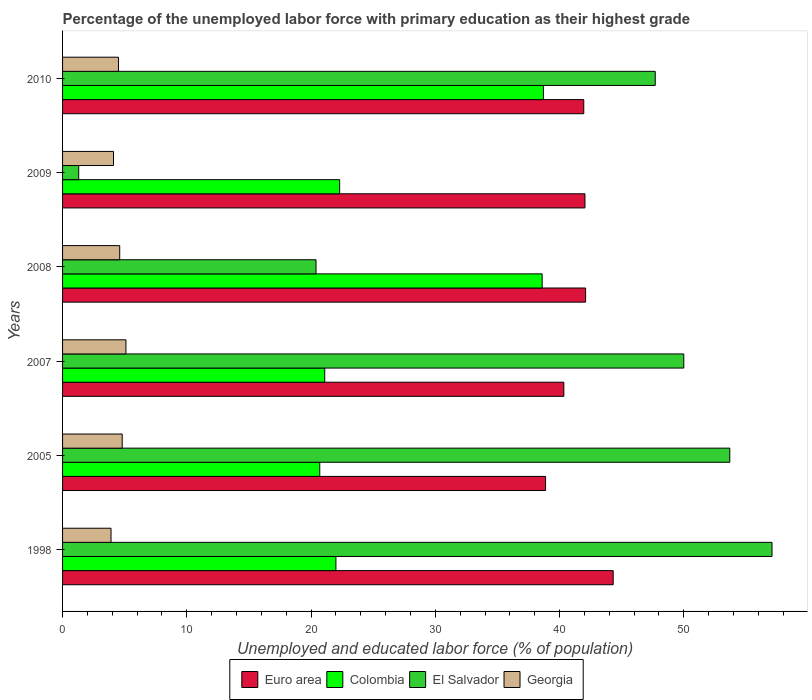How many different coloured bars are there?
Offer a terse response. 4. How many groups of bars are there?
Provide a succinct answer. 6. Are the number of bars on each tick of the Y-axis equal?
Give a very brief answer. Yes. How many bars are there on the 3rd tick from the top?
Offer a terse response. 4. What is the percentage of the unemployed labor force with primary education in Euro area in 2005?
Give a very brief answer. 38.87. Across all years, what is the maximum percentage of the unemployed labor force with primary education in El Salvador?
Offer a terse response. 57.1. Across all years, what is the minimum percentage of the unemployed labor force with primary education in Georgia?
Provide a short and direct response. 3.9. In which year was the percentage of the unemployed labor force with primary education in Georgia maximum?
Ensure brevity in your answer.  2007. What is the total percentage of the unemployed labor force with primary education in Georgia in the graph?
Keep it short and to the point. 27. What is the difference between the percentage of the unemployed labor force with primary education in Colombia in 1998 and that in 2009?
Your answer should be compact. -0.3. What is the difference between the percentage of the unemployed labor force with primary education in Euro area in 2008 and the percentage of the unemployed labor force with primary education in El Salvador in 2007?
Your answer should be compact. -7.9. What is the average percentage of the unemployed labor force with primary education in Colombia per year?
Offer a terse response. 27.23. In the year 2007, what is the difference between the percentage of the unemployed labor force with primary education in Euro area and percentage of the unemployed labor force with primary education in Colombia?
Offer a very short reply. 19.24. What is the ratio of the percentage of the unemployed labor force with primary education in Colombia in 2009 to that in 2010?
Provide a succinct answer. 0.58. Is the percentage of the unemployed labor force with primary education in Euro area in 2007 less than that in 2009?
Your answer should be very brief. Yes. What is the difference between the highest and the second highest percentage of the unemployed labor force with primary education in Colombia?
Offer a terse response. 0.1. What is the difference between the highest and the lowest percentage of the unemployed labor force with primary education in El Salvador?
Offer a terse response. 55.8. What does the 4th bar from the top in 2010 represents?
Make the answer very short. Euro area. What does the 4th bar from the bottom in 2005 represents?
Your answer should be compact. Georgia. Is it the case that in every year, the sum of the percentage of the unemployed labor force with primary education in Colombia and percentage of the unemployed labor force with primary education in El Salvador is greater than the percentage of the unemployed labor force with primary education in Georgia?
Give a very brief answer. Yes. How many bars are there?
Provide a short and direct response. 24. Are all the bars in the graph horizontal?
Your response must be concise. Yes. How many years are there in the graph?
Your response must be concise. 6. What is the difference between two consecutive major ticks on the X-axis?
Make the answer very short. 10. Does the graph contain any zero values?
Your response must be concise. No. Does the graph contain grids?
Make the answer very short. No. How are the legend labels stacked?
Give a very brief answer. Horizontal. What is the title of the graph?
Provide a succinct answer. Percentage of the unemployed labor force with primary education as their highest grade. What is the label or title of the X-axis?
Make the answer very short. Unemployed and educated labor force (% of population). What is the Unemployed and educated labor force (% of population) in Euro area in 1998?
Keep it short and to the point. 44.32. What is the Unemployed and educated labor force (% of population) of El Salvador in 1998?
Provide a succinct answer. 57.1. What is the Unemployed and educated labor force (% of population) in Georgia in 1998?
Give a very brief answer. 3.9. What is the Unemployed and educated labor force (% of population) in Euro area in 2005?
Make the answer very short. 38.87. What is the Unemployed and educated labor force (% of population) in Colombia in 2005?
Make the answer very short. 20.7. What is the Unemployed and educated labor force (% of population) in El Salvador in 2005?
Ensure brevity in your answer.  53.7. What is the Unemployed and educated labor force (% of population) of Georgia in 2005?
Give a very brief answer. 4.8. What is the Unemployed and educated labor force (% of population) in Euro area in 2007?
Provide a short and direct response. 40.34. What is the Unemployed and educated labor force (% of population) in Colombia in 2007?
Offer a very short reply. 21.1. What is the Unemployed and educated labor force (% of population) in El Salvador in 2007?
Provide a short and direct response. 50. What is the Unemployed and educated labor force (% of population) of Georgia in 2007?
Make the answer very short. 5.1. What is the Unemployed and educated labor force (% of population) of Euro area in 2008?
Keep it short and to the point. 42.1. What is the Unemployed and educated labor force (% of population) of Colombia in 2008?
Your answer should be very brief. 38.6. What is the Unemployed and educated labor force (% of population) in El Salvador in 2008?
Keep it short and to the point. 20.4. What is the Unemployed and educated labor force (% of population) in Georgia in 2008?
Offer a very short reply. 4.6. What is the Unemployed and educated labor force (% of population) in Euro area in 2009?
Provide a short and direct response. 42.04. What is the Unemployed and educated labor force (% of population) of Colombia in 2009?
Keep it short and to the point. 22.3. What is the Unemployed and educated labor force (% of population) in El Salvador in 2009?
Offer a very short reply. 1.3. What is the Unemployed and educated labor force (% of population) of Georgia in 2009?
Provide a succinct answer. 4.1. What is the Unemployed and educated labor force (% of population) in Euro area in 2010?
Provide a short and direct response. 41.95. What is the Unemployed and educated labor force (% of population) of Colombia in 2010?
Offer a terse response. 38.7. What is the Unemployed and educated labor force (% of population) of El Salvador in 2010?
Offer a terse response. 47.7. What is the Unemployed and educated labor force (% of population) of Georgia in 2010?
Your answer should be very brief. 4.5. Across all years, what is the maximum Unemployed and educated labor force (% of population) in Euro area?
Make the answer very short. 44.32. Across all years, what is the maximum Unemployed and educated labor force (% of population) in Colombia?
Offer a very short reply. 38.7. Across all years, what is the maximum Unemployed and educated labor force (% of population) in El Salvador?
Give a very brief answer. 57.1. Across all years, what is the maximum Unemployed and educated labor force (% of population) of Georgia?
Ensure brevity in your answer.  5.1. Across all years, what is the minimum Unemployed and educated labor force (% of population) of Euro area?
Your answer should be compact. 38.87. Across all years, what is the minimum Unemployed and educated labor force (% of population) in Colombia?
Offer a very short reply. 20.7. Across all years, what is the minimum Unemployed and educated labor force (% of population) of El Salvador?
Your response must be concise. 1.3. Across all years, what is the minimum Unemployed and educated labor force (% of population) of Georgia?
Your answer should be compact. 3.9. What is the total Unemployed and educated labor force (% of population) in Euro area in the graph?
Keep it short and to the point. 249.62. What is the total Unemployed and educated labor force (% of population) of Colombia in the graph?
Provide a short and direct response. 163.4. What is the total Unemployed and educated labor force (% of population) in El Salvador in the graph?
Provide a short and direct response. 230.2. What is the difference between the Unemployed and educated labor force (% of population) in Euro area in 1998 and that in 2005?
Your answer should be very brief. 5.44. What is the difference between the Unemployed and educated labor force (% of population) in Colombia in 1998 and that in 2005?
Your response must be concise. 1.3. What is the difference between the Unemployed and educated labor force (% of population) of Euro area in 1998 and that in 2007?
Provide a succinct answer. 3.97. What is the difference between the Unemployed and educated labor force (% of population) of Colombia in 1998 and that in 2007?
Provide a short and direct response. 0.9. What is the difference between the Unemployed and educated labor force (% of population) of Georgia in 1998 and that in 2007?
Your answer should be compact. -1.2. What is the difference between the Unemployed and educated labor force (% of population) of Euro area in 1998 and that in 2008?
Your response must be concise. 2.22. What is the difference between the Unemployed and educated labor force (% of population) in Colombia in 1998 and that in 2008?
Your answer should be very brief. -16.6. What is the difference between the Unemployed and educated labor force (% of population) in El Salvador in 1998 and that in 2008?
Provide a short and direct response. 36.7. What is the difference between the Unemployed and educated labor force (% of population) of Georgia in 1998 and that in 2008?
Provide a succinct answer. -0.7. What is the difference between the Unemployed and educated labor force (% of population) in Euro area in 1998 and that in 2009?
Offer a very short reply. 2.27. What is the difference between the Unemployed and educated labor force (% of population) of El Salvador in 1998 and that in 2009?
Offer a very short reply. 55.8. What is the difference between the Unemployed and educated labor force (% of population) of Georgia in 1998 and that in 2009?
Make the answer very short. -0.2. What is the difference between the Unemployed and educated labor force (% of population) of Euro area in 1998 and that in 2010?
Give a very brief answer. 2.37. What is the difference between the Unemployed and educated labor force (% of population) in Colombia in 1998 and that in 2010?
Your answer should be very brief. -16.7. What is the difference between the Unemployed and educated labor force (% of population) in El Salvador in 1998 and that in 2010?
Your answer should be compact. 9.4. What is the difference between the Unemployed and educated labor force (% of population) in Euro area in 2005 and that in 2007?
Provide a short and direct response. -1.47. What is the difference between the Unemployed and educated labor force (% of population) of Colombia in 2005 and that in 2007?
Make the answer very short. -0.4. What is the difference between the Unemployed and educated labor force (% of population) of El Salvador in 2005 and that in 2007?
Offer a terse response. 3.7. What is the difference between the Unemployed and educated labor force (% of population) of Euro area in 2005 and that in 2008?
Make the answer very short. -3.22. What is the difference between the Unemployed and educated labor force (% of population) of Colombia in 2005 and that in 2008?
Provide a short and direct response. -17.9. What is the difference between the Unemployed and educated labor force (% of population) in El Salvador in 2005 and that in 2008?
Offer a very short reply. 33.3. What is the difference between the Unemployed and educated labor force (% of population) of Georgia in 2005 and that in 2008?
Make the answer very short. 0.2. What is the difference between the Unemployed and educated labor force (% of population) in Euro area in 2005 and that in 2009?
Provide a short and direct response. -3.17. What is the difference between the Unemployed and educated labor force (% of population) in Colombia in 2005 and that in 2009?
Provide a short and direct response. -1.6. What is the difference between the Unemployed and educated labor force (% of population) in El Salvador in 2005 and that in 2009?
Your answer should be compact. 52.4. What is the difference between the Unemployed and educated labor force (% of population) in Georgia in 2005 and that in 2009?
Give a very brief answer. 0.7. What is the difference between the Unemployed and educated labor force (% of population) of Euro area in 2005 and that in 2010?
Provide a short and direct response. -3.08. What is the difference between the Unemployed and educated labor force (% of population) in Colombia in 2005 and that in 2010?
Offer a terse response. -18. What is the difference between the Unemployed and educated labor force (% of population) in Euro area in 2007 and that in 2008?
Give a very brief answer. -1.75. What is the difference between the Unemployed and educated labor force (% of population) of Colombia in 2007 and that in 2008?
Offer a very short reply. -17.5. What is the difference between the Unemployed and educated labor force (% of population) of El Salvador in 2007 and that in 2008?
Your answer should be compact. 29.6. What is the difference between the Unemployed and educated labor force (% of population) of Euro area in 2007 and that in 2009?
Your response must be concise. -1.7. What is the difference between the Unemployed and educated labor force (% of population) in El Salvador in 2007 and that in 2009?
Ensure brevity in your answer.  48.7. What is the difference between the Unemployed and educated labor force (% of population) in Euro area in 2007 and that in 2010?
Offer a terse response. -1.6. What is the difference between the Unemployed and educated labor force (% of population) in Colombia in 2007 and that in 2010?
Keep it short and to the point. -17.6. What is the difference between the Unemployed and educated labor force (% of population) of El Salvador in 2007 and that in 2010?
Provide a succinct answer. 2.3. What is the difference between the Unemployed and educated labor force (% of population) in Georgia in 2007 and that in 2010?
Ensure brevity in your answer.  0.6. What is the difference between the Unemployed and educated labor force (% of population) in Euro area in 2008 and that in 2009?
Your answer should be compact. 0.05. What is the difference between the Unemployed and educated labor force (% of population) of Colombia in 2008 and that in 2009?
Your response must be concise. 16.3. What is the difference between the Unemployed and educated labor force (% of population) in El Salvador in 2008 and that in 2009?
Provide a succinct answer. 19.1. What is the difference between the Unemployed and educated labor force (% of population) in Euro area in 2008 and that in 2010?
Keep it short and to the point. 0.15. What is the difference between the Unemployed and educated labor force (% of population) in El Salvador in 2008 and that in 2010?
Offer a very short reply. -27.3. What is the difference between the Unemployed and educated labor force (% of population) of Georgia in 2008 and that in 2010?
Provide a short and direct response. 0.1. What is the difference between the Unemployed and educated labor force (% of population) in Euro area in 2009 and that in 2010?
Give a very brief answer. 0.1. What is the difference between the Unemployed and educated labor force (% of population) in Colombia in 2009 and that in 2010?
Your response must be concise. -16.4. What is the difference between the Unemployed and educated labor force (% of population) in El Salvador in 2009 and that in 2010?
Offer a very short reply. -46.4. What is the difference between the Unemployed and educated labor force (% of population) of Georgia in 2009 and that in 2010?
Offer a terse response. -0.4. What is the difference between the Unemployed and educated labor force (% of population) in Euro area in 1998 and the Unemployed and educated labor force (% of population) in Colombia in 2005?
Provide a short and direct response. 23.62. What is the difference between the Unemployed and educated labor force (% of population) of Euro area in 1998 and the Unemployed and educated labor force (% of population) of El Salvador in 2005?
Your answer should be compact. -9.38. What is the difference between the Unemployed and educated labor force (% of population) of Euro area in 1998 and the Unemployed and educated labor force (% of population) of Georgia in 2005?
Give a very brief answer. 39.52. What is the difference between the Unemployed and educated labor force (% of population) of Colombia in 1998 and the Unemployed and educated labor force (% of population) of El Salvador in 2005?
Offer a terse response. -31.7. What is the difference between the Unemployed and educated labor force (% of population) in Colombia in 1998 and the Unemployed and educated labor force (% of population) in Georgia in 2005?
Provide a short and direct response. 17.2. What is the difference between the Unemployed and educated labor force (% of population) in El Salvador in 1998 and the Unemployed and educated labor force (% of population) in Georgia in 2005?
Your response must be concise. 52.3. What is the difference between the Unemployed and educated labor force (% of population) of Euro area in 1998 and the Unemployed and educated labor force (% of population) of Colombia in 2007?
Your answer should be compact. 23.22. What is the difference between the Unemployed and educated labor force (% of population) of Euro area in 1998 and the Unemployed and educated labor force (% of population) of El Salvador in 2007?
Ensure brevity in your answer.  -5.68. What is the difference between the Unemployed and educated labor force (% of population) in Euro area in 1998 and the Unemployed and educated labor force (% of population) in Georgia in 2007?
Offer a terse response. 39.22. What is the difference between the Unemployed and educated labor force (% of population) in Colombia in 1998 and the Unemployed and educated labor force (% of population) in El Salvador in 2007?
Your answer should be compact. -28. What is the difference between the Unemployed and educated labor force (% of population) in Colombia in 1998 and the Unemployed and educated labor force (% of population) in Georgia in 2007?
Make the answer very short. 16.9. What is the difference between the Unemployed and educated labor force (% of population) of El Salvador in 1998 and the Unemployed and educated labor force (% of population) of Georgia in 2007?
Ensure brevity in your answer.  52. What is the difference between the Unemployed and educated labor force (% of population) in Euro area in 1998 and the Unemployed and educated labor force (% of population) in Colombia in 2008?
Offer a very short reply. 5.72. What is the difference between the Unemployed and educated labor force (% of population) of Euro area in 1998 and the Unemployed and educated labor force (% of population) of El Salvador in 2008?
Keep it short and to the point. 23.92. What is the difference between the Unemployed and educated labor force (% of population) in Euro area in 1998 and the Unemployed and educated labor force (% of population) in Georgia in 2008?
Offer a very short reply. 39.72. What is the difference between the Unemployed and educated labor force (% of population) in El Salvador in 1998 and the Unemployed and educated labor force (% of population) in Georgia in 2008?
Ensure brevity in your answer.  52.5. What is the difference between the Unemployed and educated labor force (% of population) of Euro area in 1998 and the Unemployed and educated labor force (% of population) of Colombia in 2009?
Keep it short and to the point. 22.02. What is the difference between the Unemployed and educated labor force (% of population) of Euro area in 1998 and the Unemployed and educated labor force (% of population) of El Salvador in 2009?
Your response must be concise. 43.02. What is the difference between the Unemployed and educated labor force (% of population) of Euro area in 1998 and the Unemployed and educated labor force (% of population) of Georgia in 2009?
Provide a succinct answer. 40.22. What is the difference between the Unemployed and educated labor force (% of population) in Colombia in 1998 and the Unemployed and educated labor force (% of population) in El Salvador in 2009?
Your answer should be very brief. 20.7. What is the difference between the Unemployed and educated labor force (% of population) of Colombia in 1998 and the Unemployed and educated labor force (% of population) of Georgia in 2009?
Offer a very short reply. 17.9. What is the difference between the Unemployed and educated labor force (% of population) in Euro area in 1998 and the Unemployed and educated labor force (% of population) in Colombia in 2010?
Keep it short and to the point. 5.62. What is the difference between the Unemployed and educated labor force (% of population) in Euro area in 1998 and the Unemployed and educated labor force (% of population) in El Salvador in 2010?
Provide a succinct answer. -3.38. What is the difference between the Unemployed and educated labor force (% of population) of Euro area in 1998 and the Unemployed and educated labor force (% of population) of Georgia in 2010?
Make the answer very short. 39.82. What is the difference between the Unemployed and educated labor force (% of population) in Colombia in 1998 and the Unemployed and educated labor force (% of population) in El Salvador in 2010?
Give a very brief answer. -25.7. What is the difference between the Unemployed and educated labor force (% of population) in Colombia in 1998 and the Unemployed and educated labor force (% of population) in Georgia in 2010?
Your answer should be compact. 17.5. What is the difference between the Unemployed and educated labor force (% of population) of El Salvador in 1998 and the Unemployed and educated labor force (% of population) of Georgia in 2010?
Your answer should be very brief. 52.6. What is the difference between the Unemployed and educated labor force (% of population) of Euro area in 2005 and the Unemployed and educated labor force (% of population) of Colombia in 2007?
Provide a short and direct response. 17.77. What is the difference between the Unemployed and educated labor force (% of population) in Euro area in 2005 and the Unemployed and educated labor force (% of population) in El Salvador in 2007?
Provide a short and direct response. -11.13. What is the difference between the Unemployed and educated labor force (% of population) in Euro area in 2005 and the Unemployed and educated labor force (% of population) in Georgia in 2007?
Give a very brief answer. 33.77. What is the difference between the Unemployed and educated labor force (% of population) in Colombia in 2005 and the Unemployed and educated labor force (% of population) in El Salvador in 2007?
Provide a short and direct response. -29.3. What is the difference between the Unemployed and educated labor force (% of population) of El Salvador in 2005 and the Unemployed and educated labor force (% of population) of Georgia in 2007?
Ensure brevity in your answer.  48.6. What is the difference between the Unemployed and educated labor force (% of population) in Euro area in 2005 and the Unemployed and educated labor force (% of population) in Colombia in 2008?
Give a very brief answer. 0.27. What is the difference between the Unemployed and educated labor force (% of population) in Euro area in 2005 and the Unemployed and educated labor force (% of population) in El Salvador in 2008?
Provide a short and direct response. 18.47. What is the difference between the Unemployed and educated labor force (% of population) of Euro area in 2005 and the Unemployed and educated labor force (% of population) of Georgia in 2008?
Offer a terse response. 34.27. What is the difference between the Unemployed and educated labor force (% of population) in Colombia in 2005 and the Unemployed and educated labor force (% of population) in El Salvador in 2008?
Make the answer very short. 0.3. What is the difference between the Unemployed and educated labor force (% of population) of Colombia in 2005 and the Unemployed and educated labor force (% of population) of Georgia in 2008?
Your response must be concise. 16.1. What is the difference between the Unemployed and educated labor force (% of population) of El Salvador in 2005 and the Unemployed and educated labor force (% of population) of Georgia in 2008?
Offer a terse response. 49.1. What is the difference between the Unemployed and educated labor force (% of population) of Euro area in 2005 and the Unemployed and educated labor force (% of population) of Colombia in 2009?
Your answer should be compact. 16.57. What is the difference between the Unemployed and educated labor force (% of population) in Euro area in 2005 and the Unemployed and educated labor force (% of population) in El Salvador in 2009?
Ensure brevity in your answer.  37.57. What is the difference between the Unemployed and educated labor force (% of population) in Euro area in 2005 and the Unemployed and educated labor force (% of population) in Georgia in 2009?
Your answer should be compact. 34.77. What is the difference between the Unemployed and educated labor force (% of population) of Colombia in 2005 and the Unemployed and educated labor force (% of population) of Georgia in 2009?
Ensure brevity in your answer.  16.6. What is the difference between the Unemployed and educated labor force (% of population) in El Salvador in 2005 and the Unemployed and educated labor force (% of population) in Georgia in 2009?
Keep it short and to the point. 49.6. What is the difference between the Unemployed and educated labor force (% of population) in Euro area in 2005 and the Unemployed and educated labor force (% of population) in Colombia in 2010?
Provide a short and direct response. 0.17. What is the difference between the Unemployed and educated labor force (% of population) of Euro area in 2005 and the Unemployed and educated labor force (% of population) of El Salvador in 2010?
Make the answer very short. -8.83. What is the difference between the Unemployed and educated labor force (% of population) in Euro area in 2005 and the Unemployed and educated labor force (% of population) in Georgia in 2010?
Give a very brief answer. 34.37. What is the difference between the Unemployed and educated labor force (% of population) of Colombia in 2005 and the Unemployed and educated labor force (% of population) of Georgia in 2010?
Keep it short and to the point. 16.2. What is the difference between the Unemployed and educated labor force (% of population) of El Salvador in 2005 and the Unemployed and educated labor force (% of population) of Georgia in 2010?
Your answer should be compact. 49.2. What is the difference between the Unemployed and educated labor force (% of population) in Euro area in 2007 and the Unemployed and educated labor force (% of population) in Colombia in 2008?
Provide a succinct answer. 1.75. What is the difference between the Unemployed and educated labor force (% of population) in Euro area in 2007 and the Unemployed and educated labor force (% of population) in El Salvador in 2008?
Keep it short and to the point. 19.95. What is the difference between the Unemployed and educated labor force (% of population) of Euro area in 2007 and the Unemployed and educated labor force (% of population) of Georgia in 2008?
Your response must be concise. 35.74. What is the difference between the Unemployed and educated labor force (% of population) in Colombia in 2007 and the Unemployed and educated labor force (% of population) in Georgia in 2008?
Provide a short and direct response. 16.5. What is the difference between the Unemployed and educated labor force (% of population) of El Salvador in 2007 and the Unemployed and educated labor force (% of population) of Georgia in 2008?
Offer a very short reply. 45.4. What is the difference between the Unemployed and educated labor force (% of population) of Euro area in 2007 and the Unemployed and educated labor force (% of population) of Colombia in 2009?
Your answer should be compact. 18.05. What is the difference between the Unemployed and educated labor force (% of population) of Euro area in 2007 and the Unemployed and educated labor force (% of population) of El Salvador in 2009?
Your response must be concise. 39.05. What is the difference between the Unemployed and educated labor force (% of population) of Euro area in 2007 and the Unemployed and educated labor force (% of population) of Georgia in 2009?
Your answer should be very brief. 36.24. What is the difference between the Unemployed and educated labor force (% of population) in Colombia in 2007 and the Unemployed and educated labor force (% of population) in El Salvador in 2009?
Ensure brevity in your answer.  19.8. What is the difference between the Unemployed and educated labor force (% of population) of Colombia in 2007 and the Unemployed and educated labor force (% of population) of Georgia in 2009?
Keep it short and to the point. 17. What is the difference between the Unemployed and educated labor force (% of population) of El Salvador in 2007 and the Unemployed and educated labor force (% of population) of Georgia in 2009?
Keep it short and to the point. 45.9. What is the difference between the Unemployed and educated labor force (% of population) in Euro area in 2007 and the Unemployed and educated labor force (% of population) in Colombia in 2010?
Give a very brief answer. 1.65. What is the difference between the Unemployed and educated labor force (% of population) in Euro area in 2007 and the Unemployed and educated labor force (% of population) in El Salvador in 2010?
Your response must be concise. -7.36. What is the difference between the Unemployed and educated labor force (% of population) of Euro area in 2007 and the Unemployed and educated labor force (% of population) of Georgia in 2010?
Your response must be concise. 35.84. What is the difference between the Unemployed and educated labor force (% of population) in Colombia in 2007 and the Unemployed and educated labor force (% of population) in El Salvador in 2010?
Your response must be concise. -26.6. What is the difference between the Unemployed and educated labor force (% of population) in El Salvador in 2007 and the Unemployed and educated labor force (% of population) in Georgia in 2010?
Keep it short and to the point. 45.5. What is the difference between the Unemployed and educated labor force (% of population) of Euro area in 2008 and the Unemployed and educated labor force (% of population) of Colombia in 2009?
Keep it short and to the point. 19.8. What is the difference between the Unemployed and educated labor force (% of population) in Euro area in 2008 and the Unemployed and educated labor force (% of population) in El Salvador in 2009?
Give a very brief answer. 40.8. What is the difference between the Unemployed and educated labor force (% of population) of Euro area in 2008 and the Unemployed and educated labor force (% of population) of Georgia in 2009?
Provide a short and direct response. 38. What is the difference between the Unemployed and educated labor force (% of population) in Colombia in 2008 and the Unemployed and educated labor force (% of population) in El Salvador in 2009?
Your response must be concise. 37.3. What is the difference between the Unemployed and educated labor force (% of population) in Colombia in 2008 and the Unemployed and educated labor force (% of population) in Georgia in 2009?
Your answer should be compact. 34.5. What is the difference between the Unemployed and educated labor force (% of population) of El Salvador in 2008 and the Unemployed and educated labor force (% of population) of Georgia in 2009?
Your response must be concise. 16.3. What is the difference between the Unemployed and educated labor force (% of population) of Euro area in 2008 and the Unemployed and educated labor force (% of population) of Colombia in 2010?
Your response must be concise. 3.4. What is the difference between the Unemployed and educated labor force (% of population) in Euro area in 2008 and the Unemployed and educated labor force (% of population) in El Salvador in 2010?
Keep it short and to the point. -5.6. What is the difference between the Unemployed and educated labor force (% of population) of Euro area in 2008 and the Unemployed and educated labor force (% of population) of Georgia in 2010?
Your answer should be very brief. 37.6. What is the difference between the Unemployed and educated labor force (% of population) of Colombia in 2008 and the Unemployed and educated labor force (% of population) of El Salvador in 2010?
Make the answer very short. -9.1. What is the difference between the Unemployed and educated labor force (% of population) in Colombia in 2008 and the Unemployed and educated labor force (% of population) in Georgia in 2010?
Your answer should be very brief. 34.1. What is the difference between the Unemployed and educated labor force (% of population) in El Salvador in 2008 and the Unemployed and educated labor force (% of population) in Georgia in 2010?
Your answer should be very brief. 15.9. What is the difference between the Unemployed and educated labor force (% of population) of Euro area in 2009 and the Unemployed and educated labor force (% of population) of Colombia in 2010?
Provide a succinct answer. 3.34. What is the difference between the Unemployed and educated labor force (% of population) in Euro area in 2009 and the Unemployed and educated labor force (% of population) in El Salvador in 2010?
Ensure brevity in your answer.  -5.66. What is the difference between the Unemployed and educated labor force (% of population) of Euro area in 2009 and the Unemployed and educated labor force (% of population) of Georgia in 2010?
Offer a very short reply. 37.54. What is the difference between the Unemployed and educated labor force (% of population) of Colombia in 2009 and the Unemployed and educated labor force (% of population) of El Salvador in 2010?
Offer a very short reply. -25.4. What is the difference between the Unemployed and educated labor force (% of population) of Colombia in 2009 and the Unemployed and educated labor force (% of population) of Georgia in 2010?
Provide a succinct answer. 17.8. What is the average Unemployed and educated labor force (% of population) in Euro area per year?
Offer a terse response. 41.6. What is the average Unemployed and educated labor force (% of population) of Colombia per year?
Ensure brevity in your answer.  27.23. What is the average Unemployed and educated labor force (% of population) in El Salvador per year?
Make the answer very short. 38.37. In the year 1998, what is the difference between the Unemployed and educated labor force (% of population) of Euro area and Unemployed and educated labor force (% of population) of Colombia?
Your answer should be compact. 22.32. In the year 1998, what is the difference between the Unemployed and educated labor force (% of population) of Euro area and Unemployed and educated labor force (% of population) of El Salvador?
Your answer should be very brief. -12.78. In the year 1998, what is the difference between the Unemployed and educated labor force (% of population) of Euro area and Unemployed and educated labor force (% of population) of Georgia?
Offer a terse response. 40.42. In the year 1998, what is the difference between the Unemployed and educated labor force (% of population) of Colombia and Unemployed and educated labor force (% of population) of El Salvador?
Give a very brief answer. -35.1. In the year 1998, what is the difference between the Unemployed and educated labor force (% of population) in Colombia and Unemployed and educated labor force (% of population) in Georgia?
Make the answer very short. 18.1. In the year 1998, what is the difference between the Unemployed and educated labor force (% of population) in El Salvador and Unemployed and educated labor force (% of population) in Georgia?
Your answer should be compact. 53.2. In the year 2005, what is the difference between the Unemployed and educated labor force (% of population) of Euro area and Unemployed and educated labor force (% of population) of Colombia?
Keep it short and to the point. 18.17. In the year 2005, what is the difference between the Unemployed and educated labor force (% of population) in Euro area and Unemployed and educated labor force (% of population) in El Salvador?
Keep it short and to the point. -14.83. In the year 2005, what is the difference between the Unemployed and educated labor force (% of population) of Euro area and Unemployed and educated labor force (% of population) of Georgia?
Your answer should be compact. 34.07. In the year 2005, what is the difference between the Unemployed and educated labor force (% of population) in Colombia and Unemployed and educated labor force (% of population) in El Salvador?
Offer a terse response. -33. In the year 2005, what is the difference between the Unemployed and educated labor force (% of population) of Colombia and Unemployed and educated labor force (% of population) of Georgia?
Ensure brevity in your answer.  15.9. In the year 2005, what is the difference between the Unemployed and educated labor force (% of population) in El Salvador and Unemployed and educated labor force (% of population) in Georgia?
Make the answer very short. 48.9. In the year 2007, what is the difference between the Unemployed and educated labor force (% of population) in Euro area and Unemployed and educated labor force (% of population) in Colombia?
Offer a terse response. 19.25. In the year 2007, what is the difference between the Unemployed and educated labor force (% of population) of Euro area and Unemployed and educated labor force (% of population) of El Salvador?
Your response must be concise. -9.65. In the year 2007, what is the difference between the Unemployed and educated labor force (% of population) in Euro area and Unemployed and educated labor force (% of population) in Georgia?
Make the answer very short. 35.24. In the year 2007, what is the difference between the Unemployed and educated labor force (% of population) in Colombia and Unemployed and educated labor force (% of population) in El Salvador?
Offer a terse response. -28.9. In the year 2007, what is the difference between the Unemployed and educated labor force (% of population) in El Salvador and Unemployed and educated labor force (% of population) in Georgia?
Keep it short and to the point. 44.9. In the year 2008, what is the difference between the Unemployed and educated labor force (% of population) in Euro area and Unemployed and educated labor force (% of population) in Colombia?
Give a very brief answer. 3.5. In the year 2008, what is the difference between the Unemployed and educated labor force (% of population) of Euro area and Unemployed and educated labor force (% of population) of El Salvador?
Your answer should be very brief. 21.7. In the year 2008, what is the difference between the Unemployed and educated labor force (% of population) in Euro area and Unemployed and educated labor force (% of population) in Georgia?
Offer a very short reply. 37.5. In the year 2008, what is the difference between the Unemployed and educated labor force (% of population) in Colombia and Unemployed and educated labor force (% of population) in El Salvador?
Your response must be concise. 18.2. In the year 2008, what is the difference between the Unemployed and educated labor force (% of population) of El Salvador and Unemployed and educated labor force (% of population) of Georgia?
Offer a very short reply. 15.8. In the year 2009, what is the difference between the Unemployed and educated labor force (% of population) of Euro area and Unemployed and educated labor force (% of population) of Colombia?
Offer a very short reply. 19.74. In the year 2009, what is the difference between the Unemployed and educated labor force (% of population) of Euro area and Unemployed and educated labor force (% of population) of El Salvador?
Offer a very short reply. 40.74. In the year 2009, what is the difference between the Unemployed and educated labor force (% of population) of Euro area and Unemployed and educated labor force (% of population) of Georgia?
Your response must be concise. 37.94. In the year 2010, what is the difference between the Unemployed and educated labor force (% of population) in Euro area and Unemployed and educated labor force (% of population) in Colombia?
Offer a very short reply. 3.25. In the year 2010, what is the difference between the Unemployed and educated labor force (% of population) of Euro area and Unemployed and educated labor force (% of population) of El Salvador?
Make the answer very short. -5.75. In the year 2010, what is the difference between the Unemployed and educated labor force (% of population) of Euro area and Unemployed and educated labor force (% of population) of Georgia?
Offer a very short reply. 37.45. In the year 2010, what is the difference between the Unemployed and educated labor force (% of population) of Colombia and Unemployed and educated labor force (% of population) of Georgia?
Offer a terse response. 34.2. In the year 2010, what is the difference between the Unemployed and educated labor force (% of population) of El Salvador and Unemployed and educated labor force (% of population) of Georgia?
Ensure brevity in your answer.  43.2. What is the ratio of the Unemployed and educated labor force (% of population) of Euro area in 1998 to that in 2005?
Provide a succinct answer. 1.14. What is the ratio of the Unemployed and educated labor force (% of population) of Colombia in 1998 to that in 2005?
Offer a terse response. 1.06. What is the ratio of the Unemployed and educated labor force (% of population) of El Salvador in 1998 to that in 2005?
Your answer should be compact. 1.06. What is the ratio of the Unemployed and educated labor force (% of population) of Georgia in 1998 to that in 2005?
Give a very brief answer. 0.81. What is the ratio of the Unemployed and educated labor force (% of population) in Euro area in 1998 to that in 2007?
Make the answer very short. 1.1. What is the ratio of the Unemployed and educated labor force (% of population) in Colombia in 1998 to that in 2007?
Ensure brevity in your answer.  1.04. What is the ratio of the Unemployed and educated labor force (% of population) in El Salvador in 1998 to that in 2007?
Your response must be concise. 1.14. What is the ratio of the Unemployed and educated labor force (% of population) in Georgia in 1998 to that in 2007?
Make the answer very short. 0.76. What is the ratio of the Unemployed and educated labor force (% of population) of Euro area in 1998 to that in 2008?
Offer a terse response. 1.05. What is the ratio of the Unemployed and educated labor force (% of population) in Colombia in 1998 to that in 2008?
Offer a very short reply. 0.57. What is the ratio of the Unemployed and educated labor force (% of population) in El Salvador in 1998 to that in 2008?
Ensure brevity in your answer.  2.8. What is the ratio of the Unemployed and educated labor force (% of population) in Georgia in 1998 to that in 2008?
Provide a short and direct response. 0.85. What is the ratio of the Unemployed and educated labor force (% of population) of Euro area in 1998 to that in 2009?
Make the answer very short. 1.05. What is the ratio of the Unemployed and educated labor force (% of population) of Colombia in 1998 to that in 2009?
Your answer should be compact. 0.99. What is the ratio of the Unemployed and educated labor force (% of population) of El Salvador in 1998 to that in 2009?
Keep it short and to the point. 43.92. What is the ratio of the Unemployed and educated labor force (% of population) of Georgia in 1998 to that in 2009?
Provide a succinct answer. 0.95. What is the ratio of the Unemployed and educated labor force (% of population) of Euro area in 1998 to that in 2010?
Provide a short and direct response. 1.06. What is the ratio of the Unemployed and educated labor force (% of population) in Colombia in 1998 to that in 2010?
Offer a very short reply. 0.57. What is the ratio of the Unemployed and educated labor force (% of population) of El Salvador in 1998 to that in 2010?
Offer a terse response. 1.2. What is the ratio of the Unemployed and educated labor force (% of population) of Georgia in 1998 to that in 2010?
Offer a very short reply. 0.87. What is the ratio of the Unemployed and educated labor force (% of population) in Euro area in 2005 to that in 2007?
Provide a short and direct response. 0.96. What is the ratio of the Unemployed and educated labor force (% of population) of El Salvador in 2005 to that in 2007?
Offer a very short reply. 1.07. What is the ratio of the Unemployed and educated labor force (% of population) in Euro area in 2005 to that in 2008?
Your response must be concise. 0.92. What is the ratio of the Unemployed and educated labor force (% of population) in Colombia in 2005 to that in 2008?
Keep it short and to the point. 0.54. What is the ratio of the Unemployed and educated labor force (% of population) in El Salvador in 2005 to that in 2008?
Your answer should be compact. 2.63. What is the ratio of the Unemployed and educated labor force (% of population) in Georgia in 2005 to that in 2008?
Keep it short and to the point. 1.04. What is the ratio of the Unemployed and educated labor force (% of population) of Euro area in 2005 to that in 2009?
Make the answer very short. 0.92. What is the ratio of the Unemployed and educated labor force (% of population) in Colombia in 2005 to that in 2009?
Offer a very short reply. 0.93. What is the ratio of the Unemployed and educated labor force (% of population) in El Salvador in 2005 to that in 2009?
Offer a very short reply. 41.31. What is the ratio of the Unemployed and educated labor force (% of population) in Georgia in 2005 to that in 2009?
Provide a short and direct response. 1.17. What is the ratio of the Unemployed and educated labor force (% of population) of Euro area in 2005 to that in 2010?
Provide a short and direct response. 0.93. What is the ratio of the Unemployed and educated labor force (% of population) in Colombia in 2005 to that in 2010?
Offer a terse response. 0.53. What is the ratio of the Unemployed and educated labor force (% of population) of El Salvador in 2005 to that in 2010?
Your response must be concise. 1.13. What is the ratio of the Unemployed and educated labor force (% of population) of Georgia in 2005 to that in 2010?
Ensure brevity in your answer.  1.07. What is the ratio of the Unemployed and educated labor force (% of population) in Euro area in 2007 to that in 2008?
Provide a short and direct response. 0.96. What is the ratio of the Unemployed and educated labor force (% of population) of Colombia in 2007 to that in 2008?
Make the answer very short. 0.55. What is the ratio of the Unemployed and educated labor force (% of population) of El Salvador in 2007 to that in 2008?
Keep it short and to the point. 2.45. What is the ratio of the Unemployed and educated labor force (% of population) in Georgia in 2007 to that in 2008?
Offer a very short reply. 1.11. What is the ratio of the Unemployed and educated labor force (% of population) in Euro area in 2007 to that in 2009?
Provide a short and direct response. 0.96. What is the ratio of the Unemployed and educated labor force (% of population) of Colombia in 2007 to that in 2009?
Your response must be concise. 0.95. What is the ratio of the Unemployed and educated labor force (% of population) of El Salvador in 2007 to that in 2009?
Give a very brief answer. 38.46. What is the ratio of the Unemployed and educated labor force (% of population) of Georgia in 2007 to that in 2009?
Make the answer very short. 1.24. What is the ratio of the Unemployed and educated labor force (% of population) of Euro area in 2007 to that in 2010?
Give a very brief answer. 0.96. What is the ratio of the Unemployed and educated labor force (% of population) in Colombia in 2007 to that in 2010?
Keep it short and to the point. 0.55. What is the ratio of the Unemployed and educated labor force (% of population) of El Salvador in 2007 to that in 2010?
Ensure brevity in your answer.  1.05. What is the ratio of the Unemployed and educated labor force (% of population) of Georgia in 2007 to that in 2010?
Provide a short and direct response. 1.13. What is the ratio of the Unemployed and educated labor force (% of population) of Euro area in 2008 to that in 2009?
Make the answer very short. 1. What is the ratio of the Unemployed and educated labor force (% of population) in Colombia in 2008 to that in 2009?
Keep it short and to the point. 1.73. What is the ratio of the Unemployed and educated labor force (% of population) of El Salvador in 2008 to that in 2009?
Make the answer very short. 15.69. What is the ratio of the Unemployed and educated labor force (% of population) of Georgia in 2008 to that in 2009?
Give a very brief answer. 1.12. What is the ratio of the Unemployed and educated labor force (% of population) of Colombia in 2008 to that in 2010?
Your response must be concise. 1. What is the ratio of the Unemployed and educated labor force (% of population) of El Salvador in 2008 to that in 2010?
Your answer should be compact. 0.43. What is the ratio of the Unemployed and educated labor force (% of population) in Georgia in 2008 to that in 2010?
Offer a terse response. 1.02. What is the ratio of the Unemployed and educated labor force (% of population) of Euro area in 2009 to that in 2010?
Keep it short and to the point. 1. What is the ratio of the Unemployed and educated labor force (% of population) in Colombia in 2009 to that in 2010?
Your response must be concise. 0.58. What is the ratio of the Unemployed and educated labor force (% of population) of El Salvador in 2009 to that in 2010?
Your answer should be compact. 0.03. What is the ratio of the Unemployed and educated labor force (% of population) in Georgia in 2009 to that in 2010?
Keep it short and to the point. 0.91. What is the difference between the highest and the second highest Unemployed and educated labor force (% of population) of Euro area?
Provide a short and direct response. 2.22. What is the difference between the highest and the second highest Unemployed and educated labor force (% of population) in El Salvador?
Your answer should be very brief. 3.4. What is the difference between the highest and the lowest Unemployed and educated labor force (% of population) in Euro area?
Provide a succinct answer. 5.44. What is the difference between the highest and the lowest Unemployed and educated labor force (% of population) in El Salvador?
Ensure brevity in your answer.  55.8. What is the difference between the highest and the lowest Unemployed and educated labor force (% of population) of Georgia?
Provide a short and direct response. 1.2. 